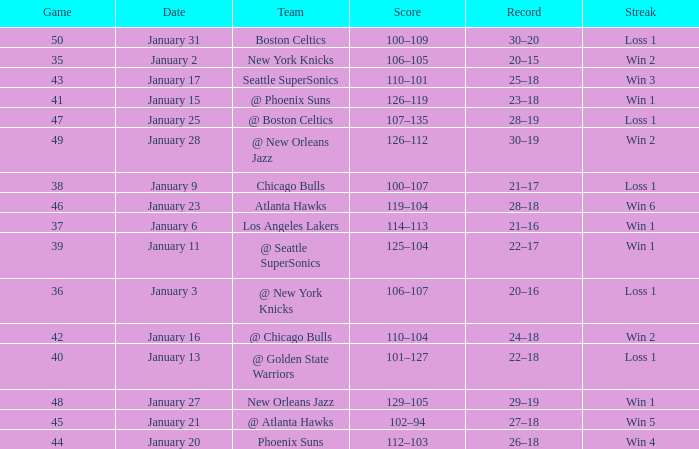What is the Streak in the game with a Record of 20–16? Loss 1. 